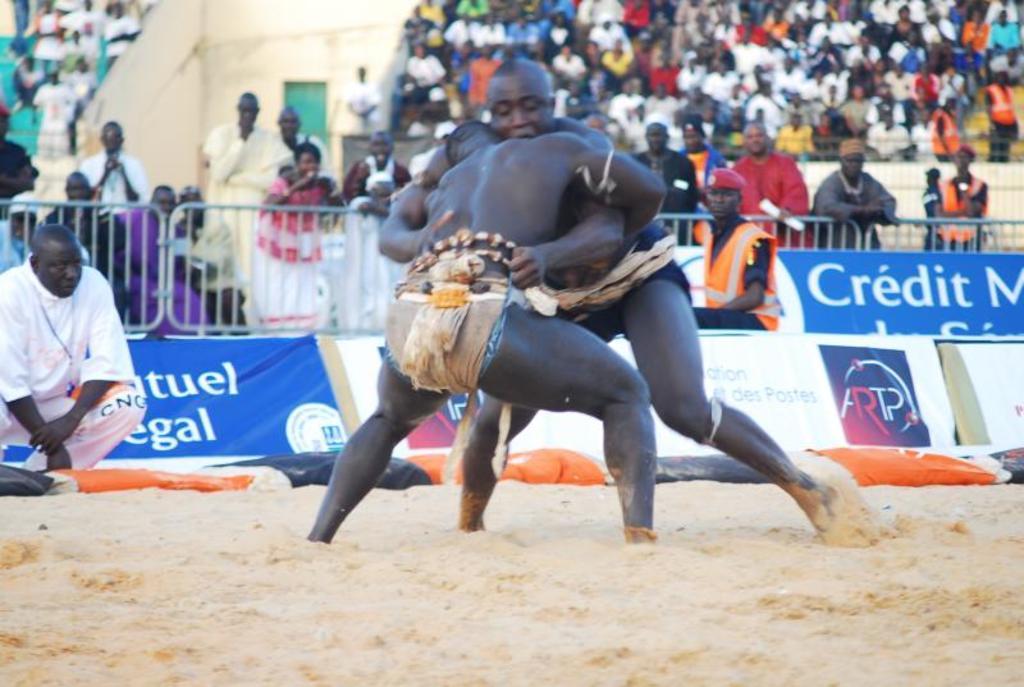In one or two sentences, can you explain what this image depicts? There are two people fighting here on the sand. In the background there are few people standing at the fence and few are sitting on the chairs. On the left there is a person in squat position and watching the two men and we can see the hoardings here. 